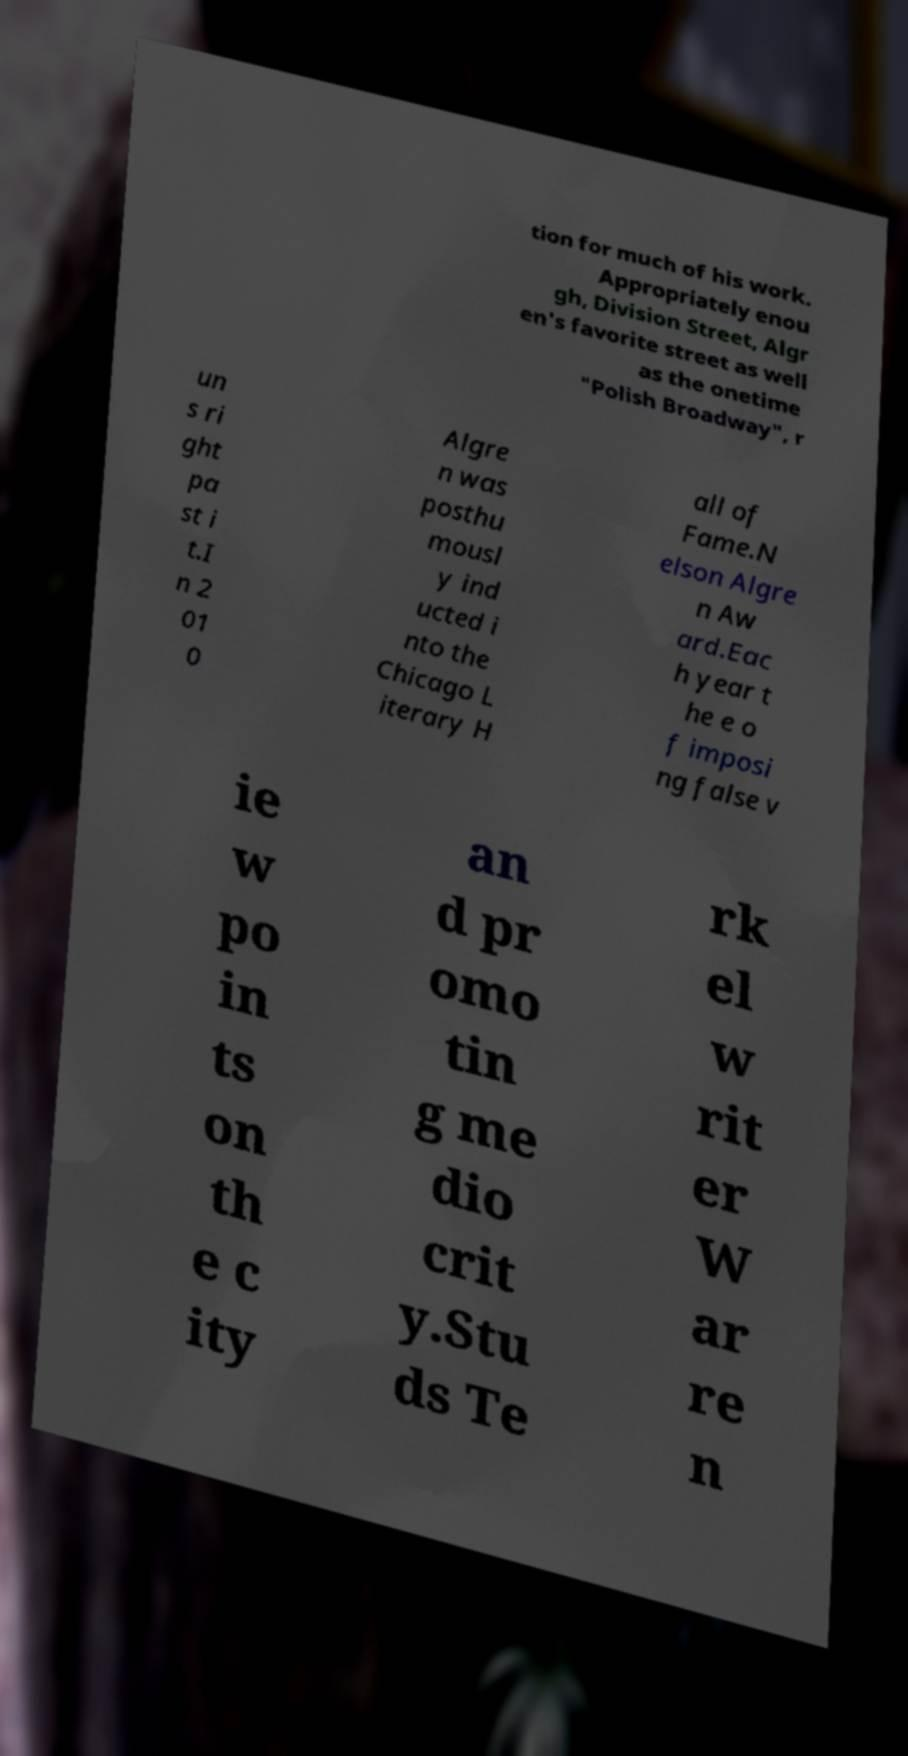Please identify and transcribe the text found in this image. tion for much of his work. Appropriately enou gh, Division Street, Algr en's favorite street as well as the onetime "Polish Broadway", r un s ri ght pa st i t.I n 2 01 0 Algre n was posthu mousl y ind ucted i nto the Chicago L iterary H all of Fame.N elson Algre n Aw ard.Eac h year t he e o f imposi ng false v ie w po in ts on th e c ity an d pr omo tin g me dio crit y.Stu ds Te rk el w rit er W ar re n 